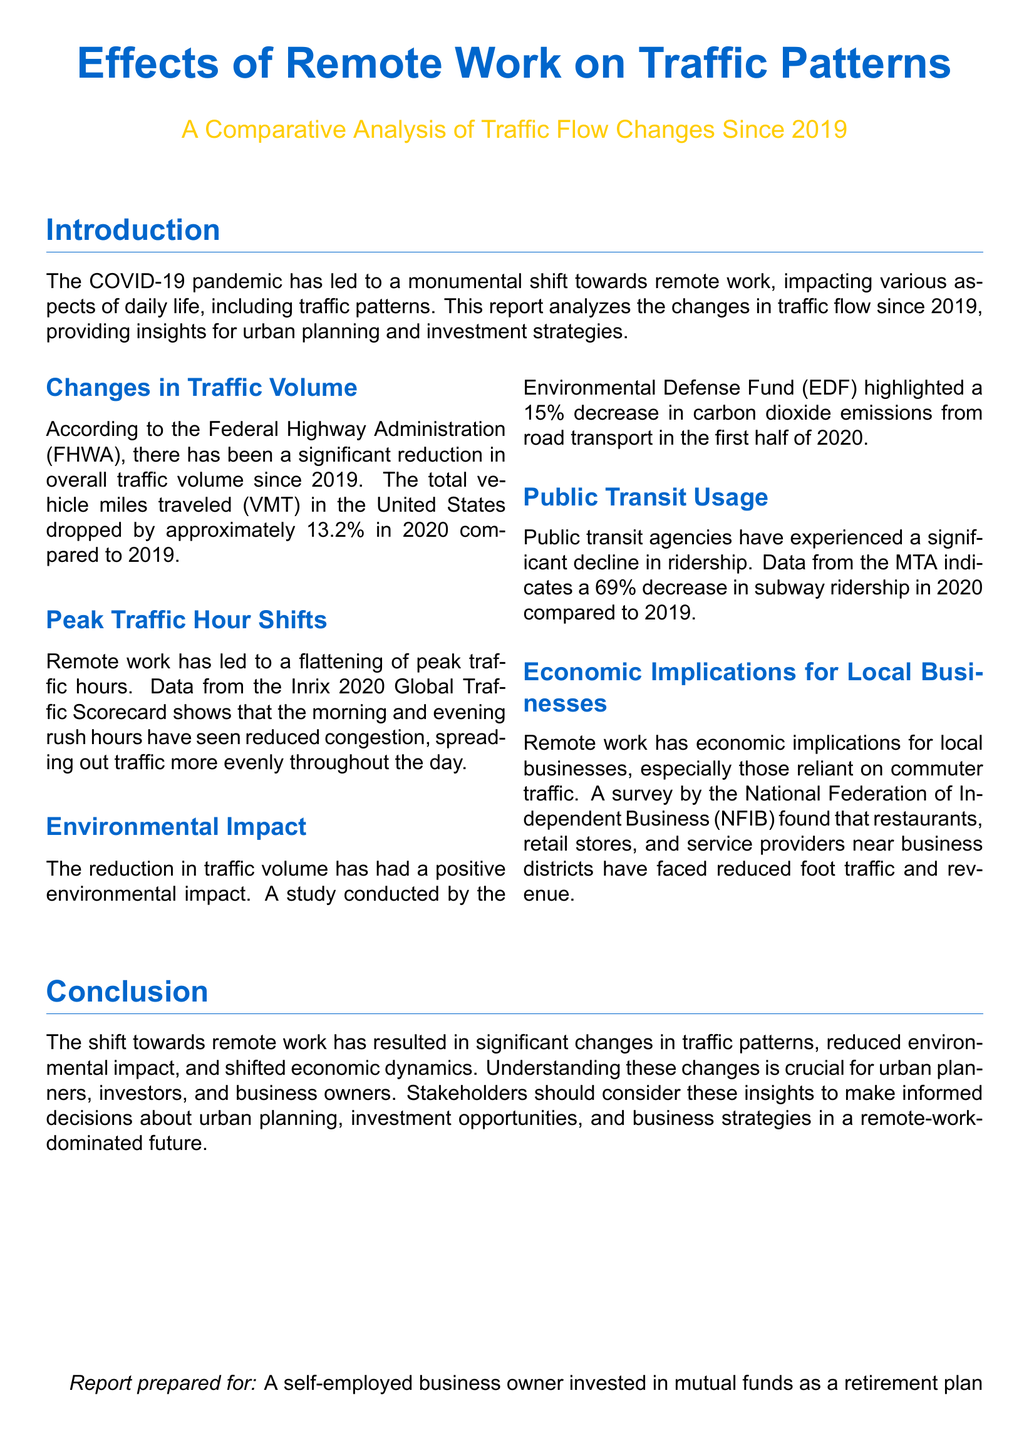What is the percentage drop in total vehicle miles traveled in 2020 compared to 2019? The total vehicle miles traveled dropped by approximately 13.2% in 2020 compared to 2019.
Answer: 13.2% What organization reported the decline in subway ridership? The document states that data from the MTA indicates a decline in subway ridership.
Answer: MTA What is one positive environmental impact mentioned in the report? The report highlighted a 15% decrease in carbon dioxide emissions from road transport in the first half of 2020.
Answer: 15% What economic effect has remote work had on local businesses? The survey by the NFIB found that local businesses faced reduced foot traffic and revenue.
Answer: Reduced foot traffic and revenue What trend has been observed in peak traffic hours since the rise of remote work? The document states that remote work has led to a flattening of peak traffic hours.
Answer: Flattening of peak traffic hours Which year serves as the baseline for this comparative analysis? The report compares changes in traffic flow since 2019.
Answer: 2019 